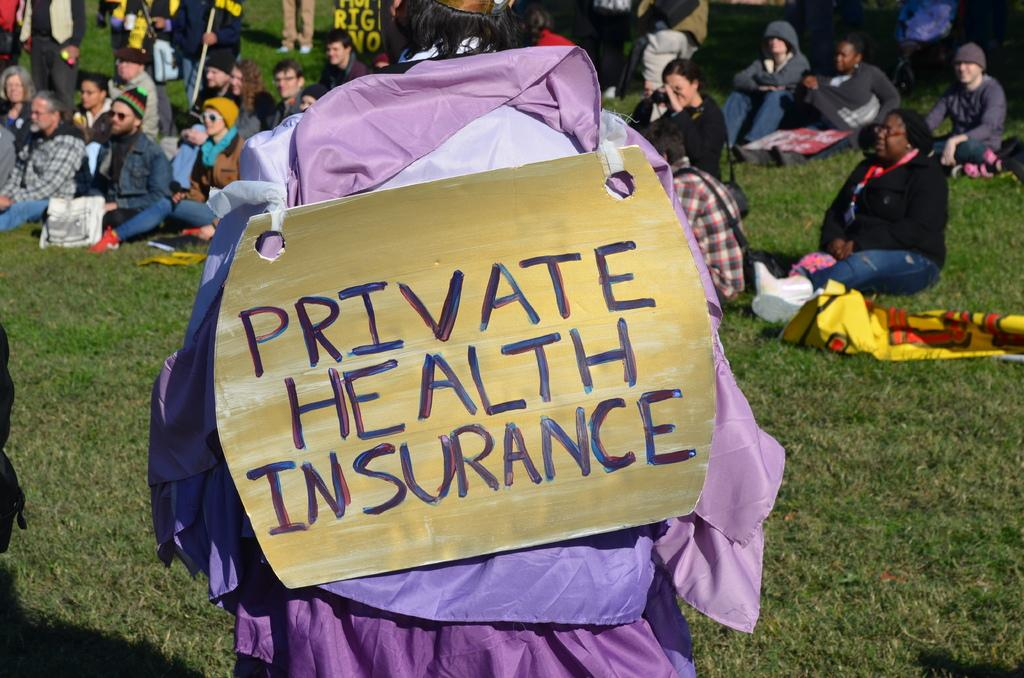What is the person in the image wearing? The person is wearing a board in the image. Which direction is the person facing? The person is facing their back. What are the people in the foreground of the image doing? People are sitting on the grass in the image. What can be seen in the background of the image? There are people standing in the background of the image. What type of seed is being planted by the yak in the image? There is no yak or seed present in the image. 